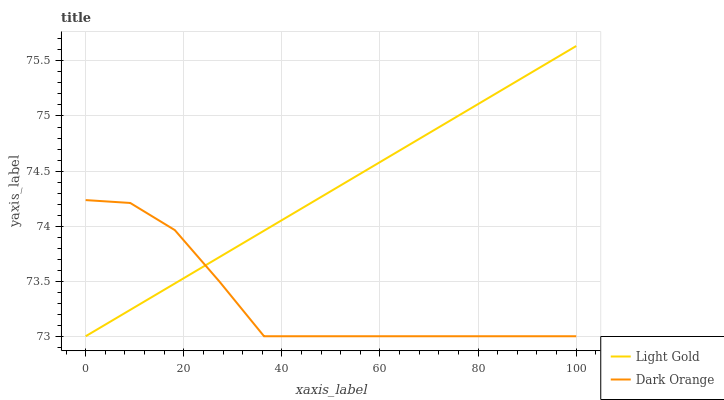Does Dark Orange have the minimum area under the curve?
Answer yes or no. Yes. Does Light Gold have the maximum area under the curve?
Answer yes or no. Yes. Does Light Gold have the minimum area under the curve?
Answer yes or no. No. Is Light Gold the smoothest?
Answer yes or no. Yes. Is Dark Orange the roughest?
Answer yes or no. Yes. Is Light Gold the roughest?
Answer yes or no. No. Does Dark Orange have the lowest value?
Answer yes or no. Yes. Does Light Gold have the highest value?
Answer yes or no. Yes. Does Dark Orange intersect Light Gold?
Answer yes or no. Yes. Is Dark Orange less than Light Gold?
Answer yes or no. No. Is Dark Orange greater than Light Gold?
Answer yes or no. No. 